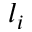<formula> <loc_0><loc_0><loc_500><loc_500>l _ { i }</formula> 